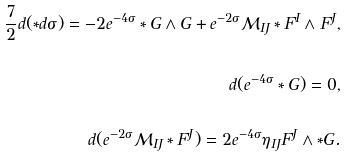<formula> <loc_0><loc_0><loc_500><loc_500>\frac { 7 } { 2 } d ( \ast d \sigma ) = - 2 e ^ { - 4 \sigma } \ast G \wedge G + e ^ { - 2 \sigma } \mathcal { M } _ { I J } \ast F ^ { I } \wedge F ^ { J } , \\ \\ d ( e ^ { - 4 \sigma } \ast G ) = 0 , \\ \\ d ( e ^ { - 2 \sigma } \mathcal { M } _ { I J } \ast F ^ { J } ) = 2 e ^ { - 4 \sigma } \eta _ { I J } F ^ { J } \wedge \ast G .</formula> 